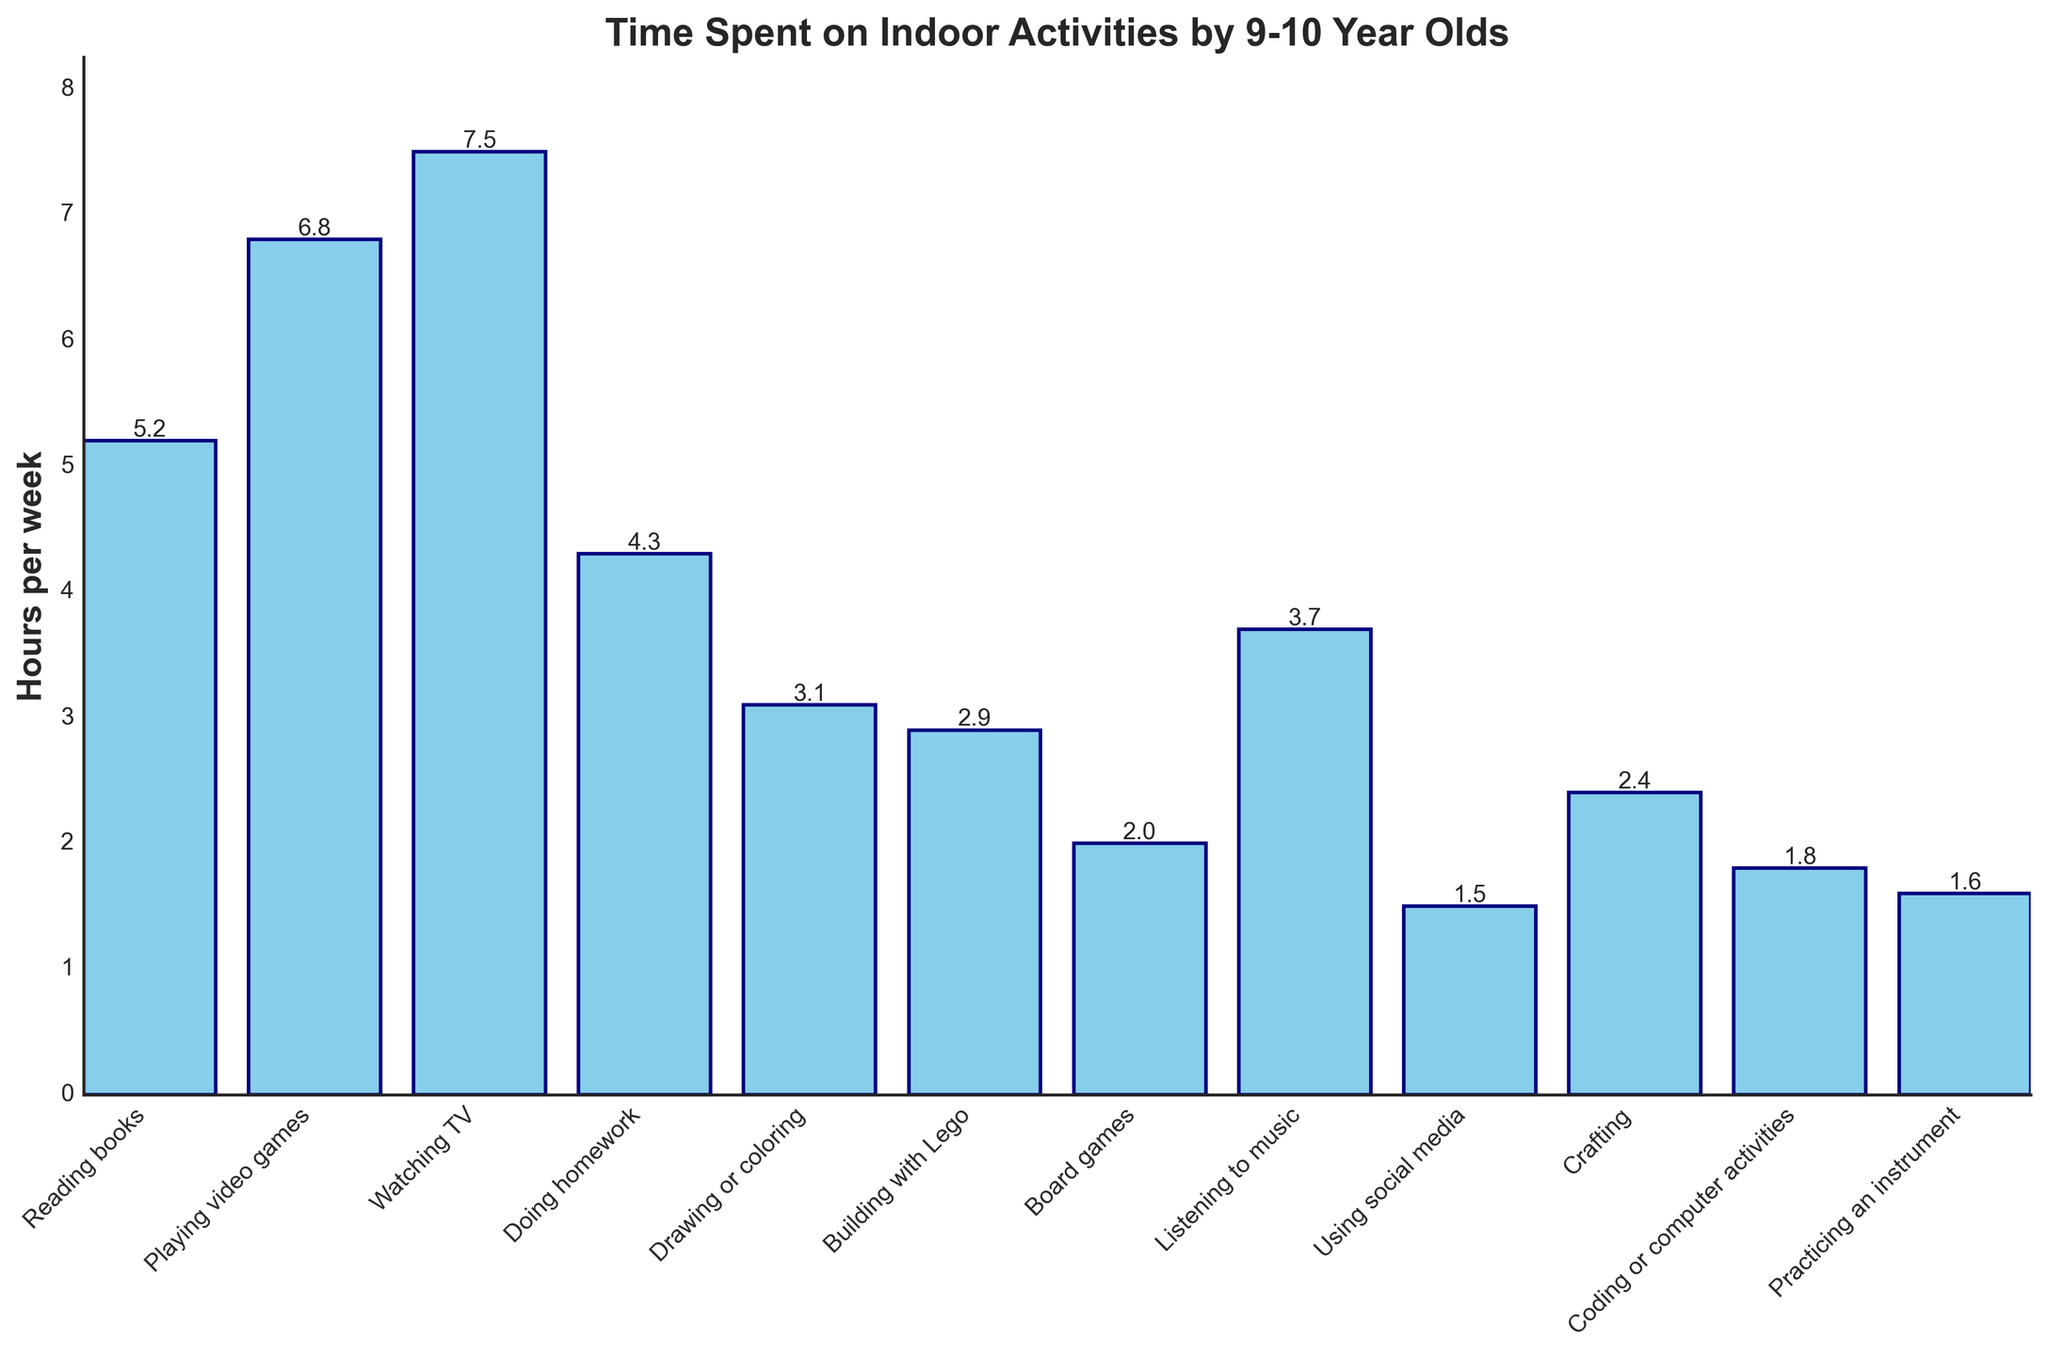What's the most popular indoor activity? The most popular indoor activity is the one with the highest bar. Watching TV has the highest bar at 7.5 hours per week.
Answer: Watching TV Which activity do kids spend the least time on? The activity with the shortest bar represents the least time spent. Using social media has the shortest bar at 1.5 hours per week.
Answer: Using social media How much more time do kids spend on reading books than on crafting? Look at the heights of the bars for reading books and crafting. Reading books: 5.2 hours, Crafting: 2.4 hours. The difference is 5.2 - 2.4 = 2.8 hours.
Answer: 2.8 hours How many hours do kids spend on all activities combined? Sum the heights of all the bars: 5.2 + 6.8 + 7.5 + 4.3 + 3.1 + 2.9 + 2.0 + 3.7 + 1.5 + 2.4 + 1.8 + 1.6 = 43.8 hours per week.
Answer: 43.8 hours Do kids spend more time playing video games or practicing an instrument? Compare the heights of the bars for playing video games and practicing an instrument. Playing video games: 6.8 hours, Practicing an instrument: 1.6 hours. 6.8 is greater than 1.6.
Answer: Playing video games What's the average time spent on doing homework and playing video games? Find the heights of the bars for doing homework and playing video games. Doing homework: 4.3 hours, Playing video games: 6.8 hours. The average is (4.3 + 6.8) / 2 = 5.55 hours.
Answer: 5.55 hours Which activity is just as popular (in terms of hours spent) as listening to music? Look at the bar height for listening to music and find another bar with the same height. Listening to music: 3.7 hours. No other activity exactly matches 3.7 hours.
Answer: None How many more hours do kids spend watching TV compared to drawing or coloring? Look at the heights of the bars for watching TV and drawing or coloring. Watching TV: 7.5 hours, Drawing or coloring: 3.1 hours. The difference is 7.5 - 3.1 = 4.4 hours.
Answer: 4.4 hours What is the total time spent on coding or computer activities, playing video games, and building with Lego? Sum the hours for each of these activities. Coding or computer activities: 1.8 hours, Playing video games: 6.8 hours, Building with Lego: 2.9 hours. The total is 1.8 + 6.8 + 2.9 = 11.5 hours.
Answer: 11.5 hours 